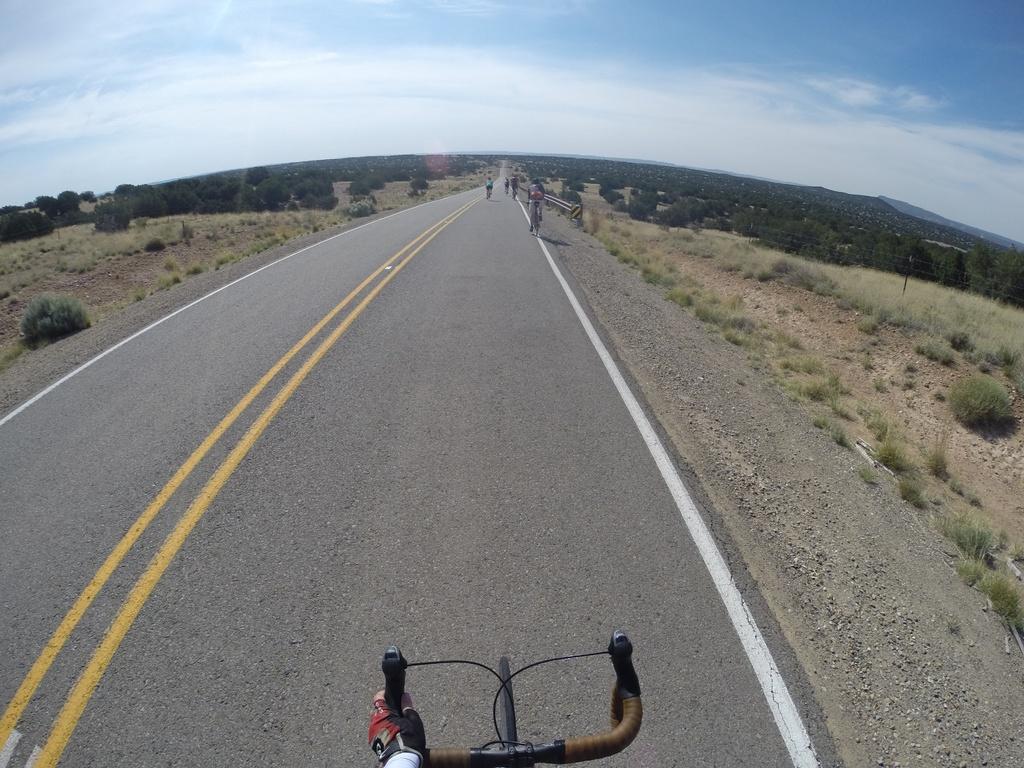How would you summarize this image in a sentence or two? In the foreground we can see road, stones, soil, person´s hand and a bicycle´s handle and tyre. In the middle of the picture we can see shrubs, bicycles, people, trees, soil, road and other objects. At the top there is sky. 